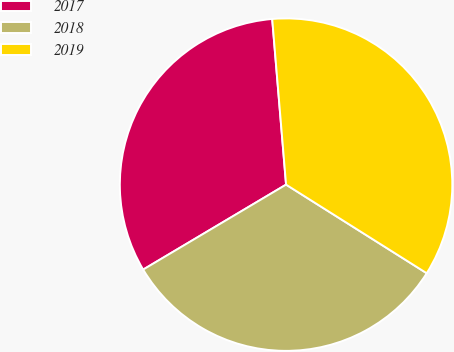Convert chart to OTSL. <chart><loc_0><loc_0><loc_500><loc_500><pie_chart><fcel>2017<fcel>2018<fcel>2019<nl><fcel>32.21%<fcel>32.52%<fcel>35.28%<nl></chart> 